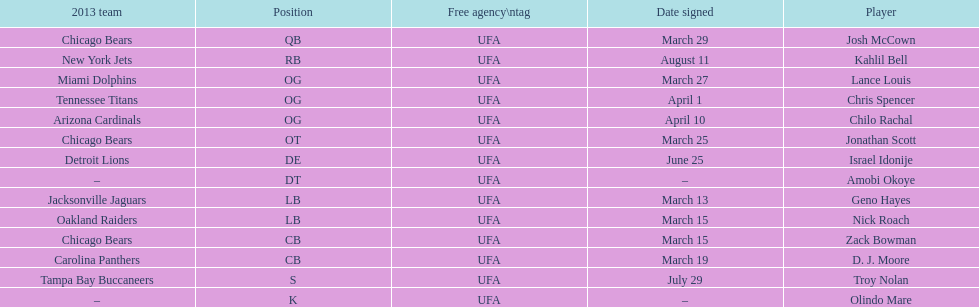Geno hayes and nick roach both played which position? LB. 